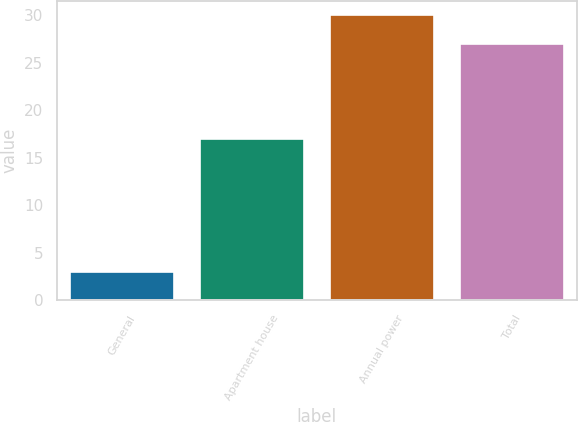<chart> <loc_0><loc_0><loc_500><loc_500><bar_chart><fcel>General<fcel>Apartment house<fcel>Annual power<fcel>Total<nl><fcel>3<fcel>17<fcel>30<fcel>27<nl></chart> 